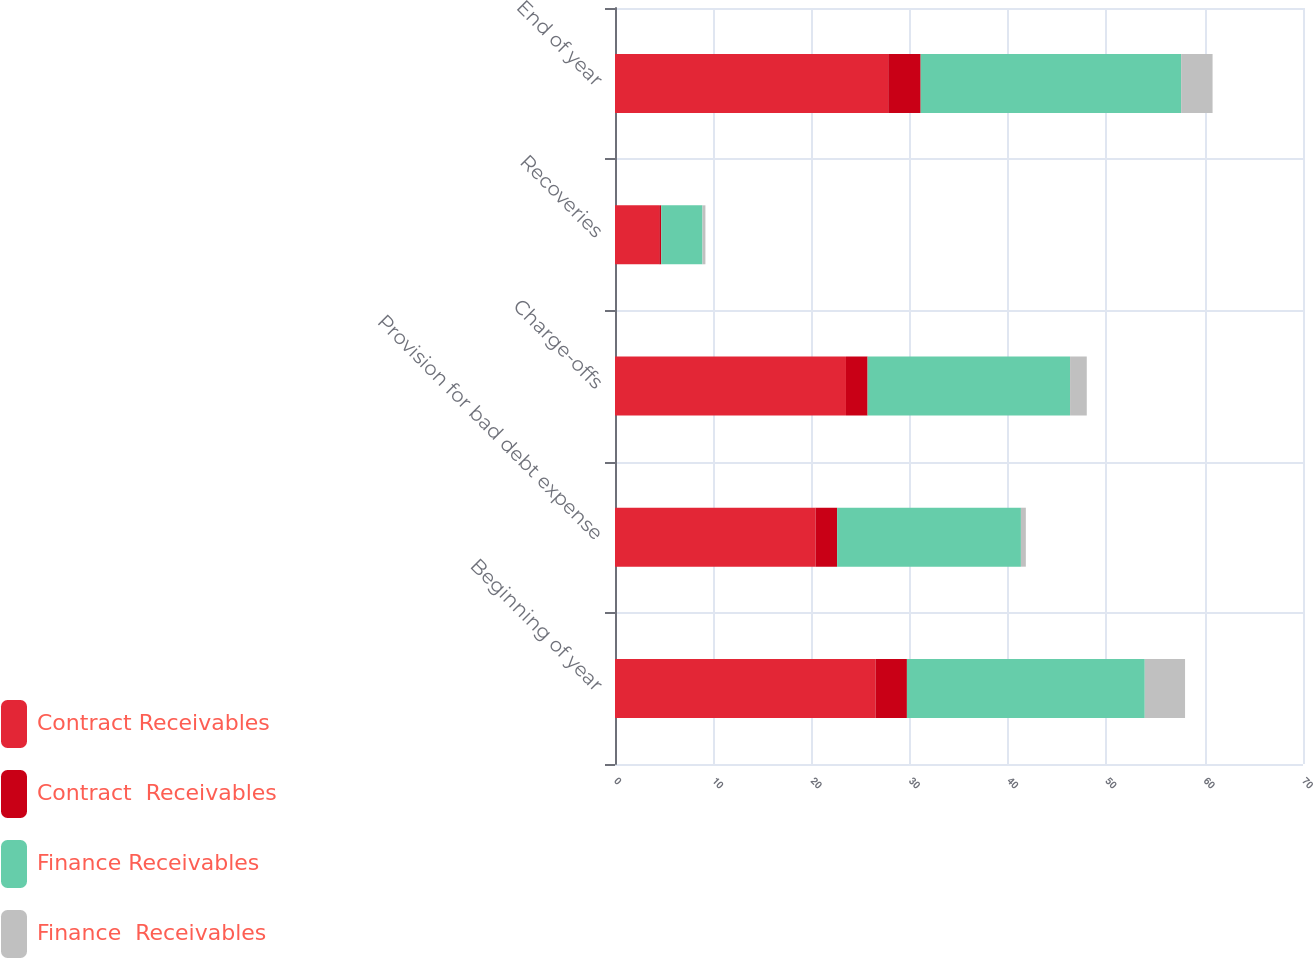Convert chart. <chart><loc_0><loc_0><loc_500><loc_500><stacked_bar_chart><ecel><fcel>Beginning of year<fcel>Provision for bad debt expense<fcel>Charge-offs<fcel>Recoveries<fcel>End of year<nl><fcel>Contract Receivables<fcel>26.5<fcel>20.4<fcel>23.5<fcel>4.5<fcel>27.8<nl><fcel>Contract  Receivables<fcel>3.2<fcel>2.2<fcel>2.2<fcel>0.2<fcel>3.3<nl><fcel>Finance Receivables<fcel>24.2<fcel>18.7<fcel>20.6<fcel>4.2<fcel>26.5<nl><fcel>Finance  Receivables<fcel>4.1<fcel>0.5<fcel>1.7<fcel>0.3<fcel>3.2<nl></chart> 